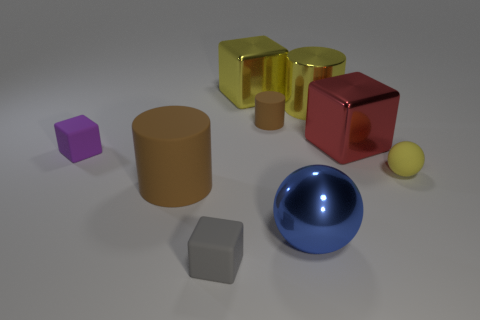Subtract 1 blocks. How many blocks are left? 3 Subtract all red shiny cubes. How many cubes are left? 3 Subtract all yellow blocks. How many blocks are left? 3 Add 1 big shiny cylinders. How many objects exist? 10 Subtract all cyan blocks. Subtract all gray spheres. How many blocks are left? 4 Subtract all cubes. How many objects are left? 5 Subtract all tiny rubber balls. Subtract all yellow metal objects. How many objects are left? 6 Add 9 large rubber cylinders. How many large rubber cylinders are left? 10 Add 2 gray things. How many gray things exist? 3 Subtract 1 blue balls. How many objects are left? 8 